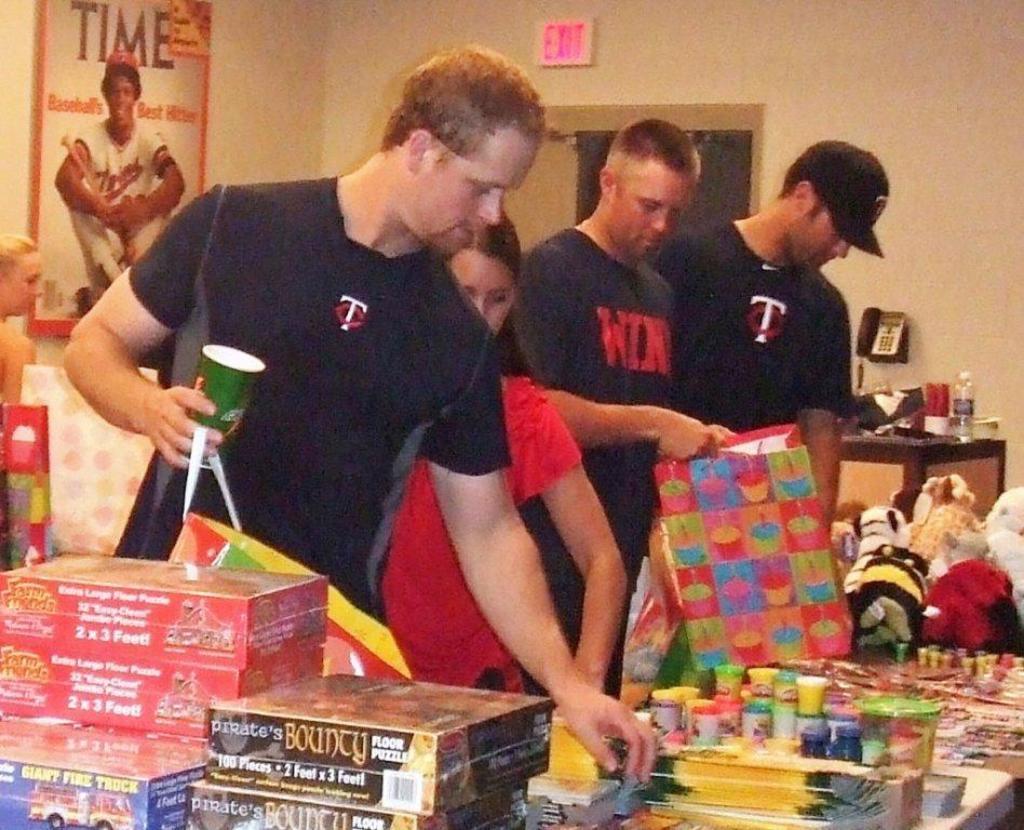Please provide a concise description of this image. There are different types of toys books and some other materials kept on the table and people are collecting those materials, in the background there is a wall and there is a poster attached to the wall and on the right side there is an exit door and beside the door there is a telephone and in front of the telephone there is a table and some items are kept on the table. 